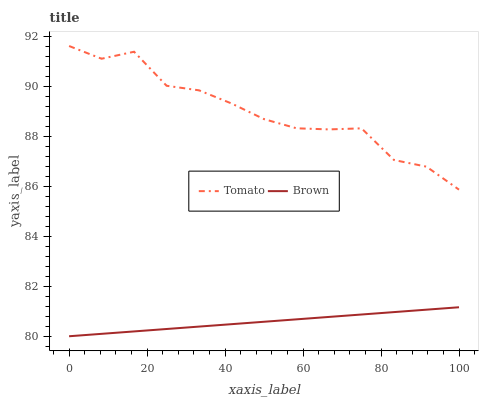Does Brown have the minimum area under the curve?
Answer yes or no. Yes. Does Tomato have the maximum area under the curve?
Answer yes or no. Yes. Does Brown have the maximum area under the curve?
Answer yes or no. No. Is Brown the smoothest?
Answer yes or no. Yes. Is Tomato the roughest?
Answer yes or no. Yes. Is Brown the roughest?
Answer yes or no. No. Does Brown have the lowest value?
Answer yes or no. Yes. Does Tomato have the highest value?
Answer yes or no. Yes. Does Brown have the highest value?
Answer yes or no. No. Is Brown less than Tomato?
Answer yes or no. Yes. Is Tomato greater than Brown?
Answer yes or no. Yes. Does Brown intersect Tomato?
Answer yes or no. No. 